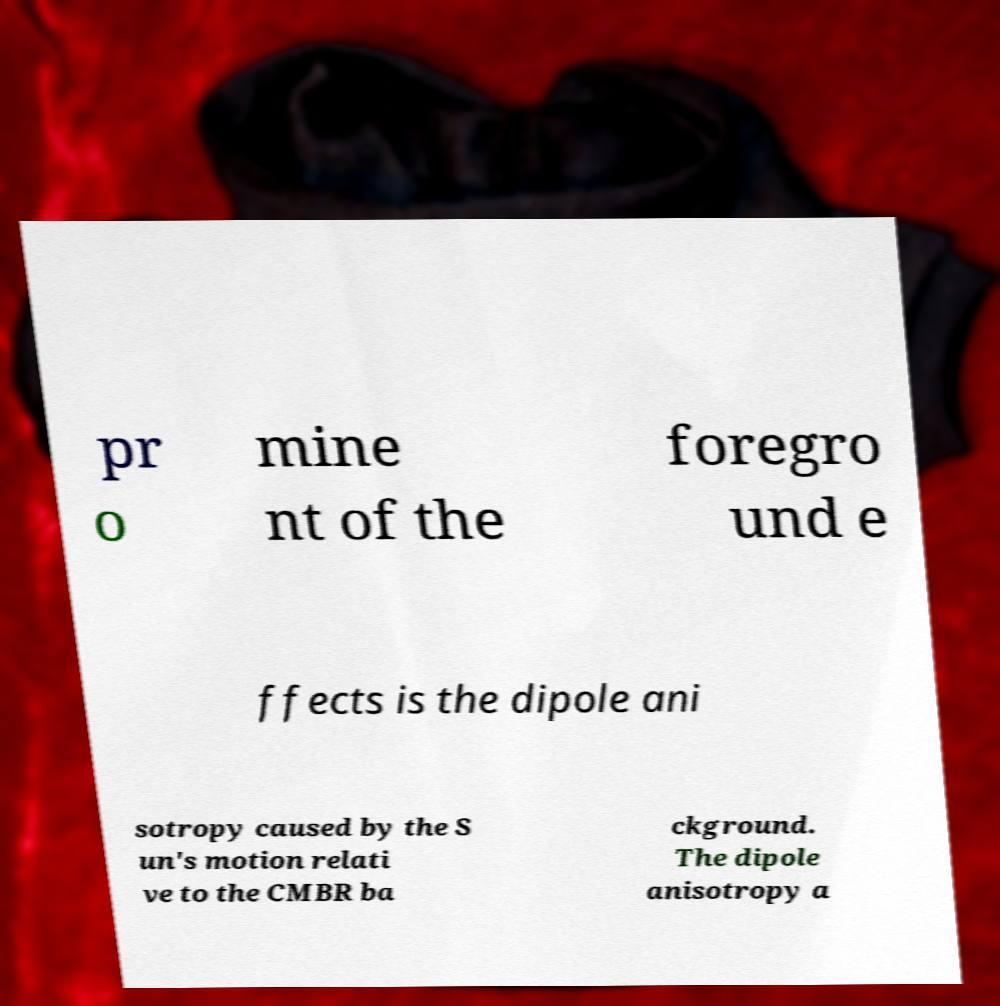Could you assist in decoding the text presented in this image and type it out clearly? pr o mine nt of the foregro und e ffects is the dipole ani sotropy caused by the S un's motion relati ve to the CMBR ba ckground. The dipole anisotropy a 